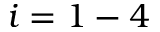<formula> <loc_0><loc_0><loc_500><loc_500>i = 1 - 4</formula> 